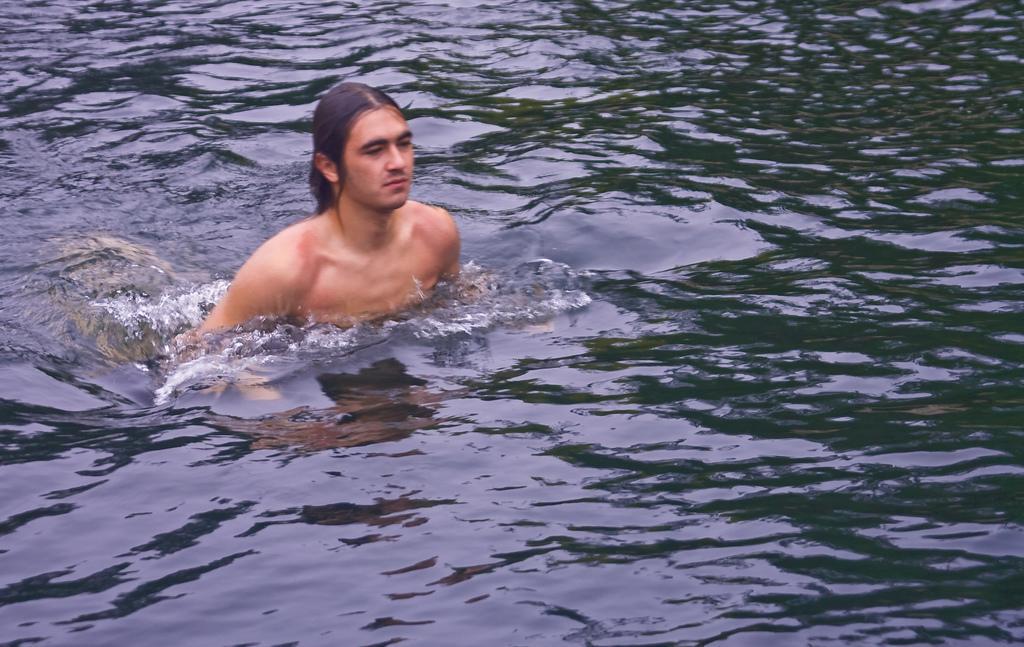Describe this image in one or two sentences. In this image we can see person bathing in water. 